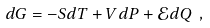<formula> <loc_0><loc_0><loc_500><loc_500>d G = - S d T + V d P + { \mathcal { E } } d Q \ ,</formula> 